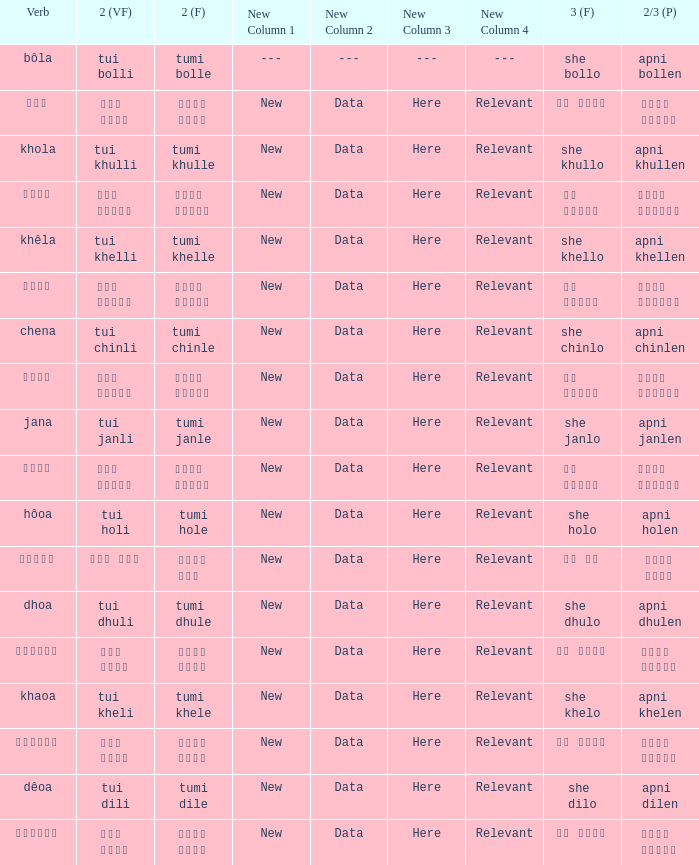What is the 3rd for the 2nd Tui Dhuli? She dhulo. 